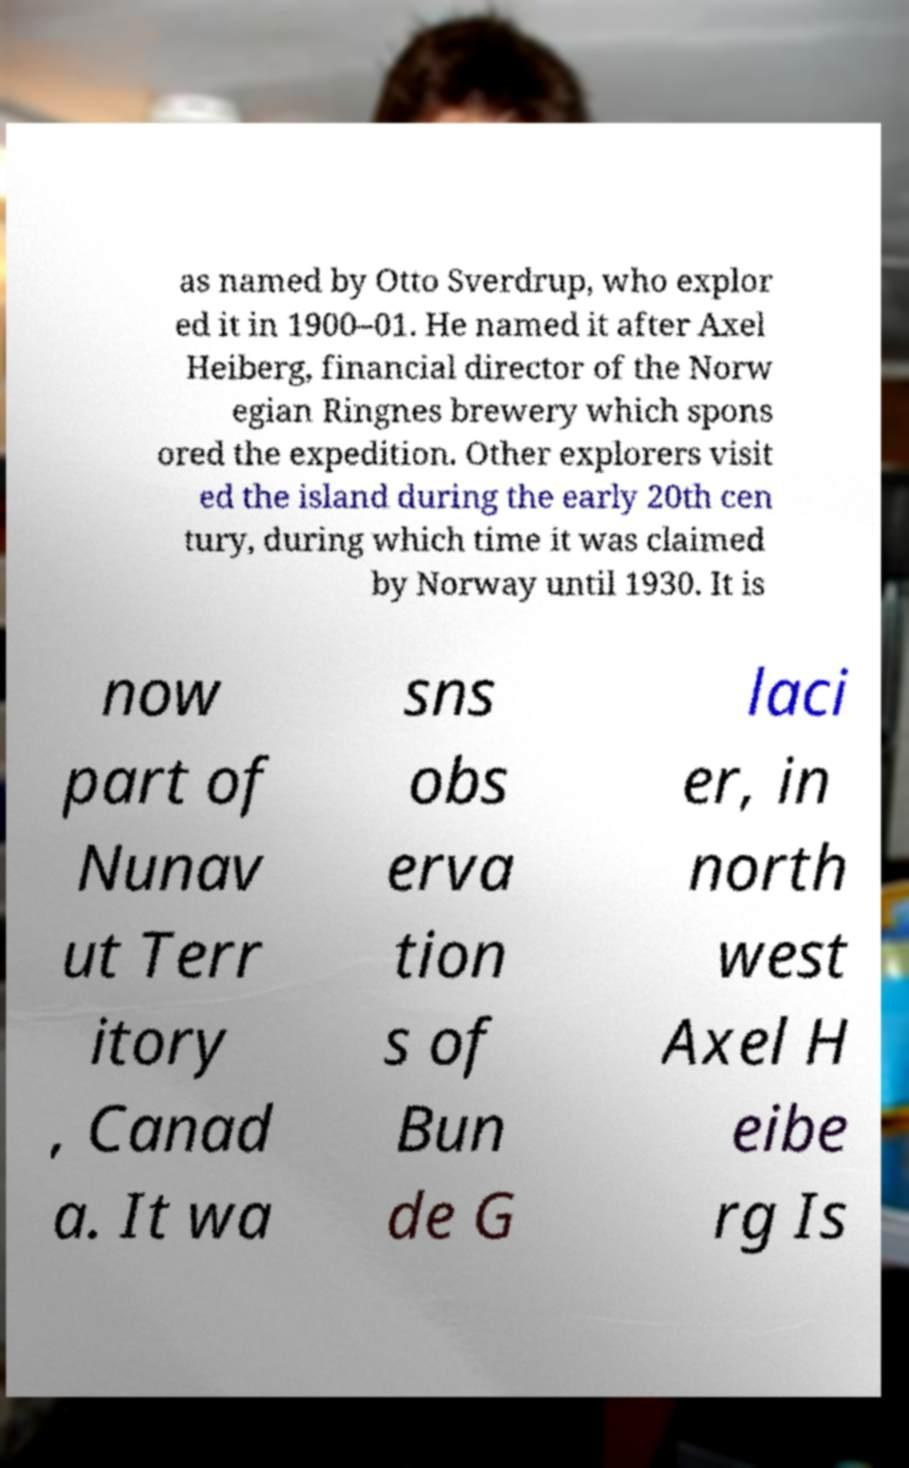Could you assist in decoding the text presented in this image and type it out clearly? as named by Otto Sverdrup, who explor ed it in 1900–01. He named it after Axel Heiberg, financial director of the Norw egian Ringnes brewery which spons ored the expedition. Other explorers visit ed the island during the early 20th cen tury, during which time it was claimed by Norway until 1930. It is now part of Nunav ut Terr itory , Canad a. It wa sns obs erva tion s of Bun de G laci er, in north west Axel H eibe rg Is 